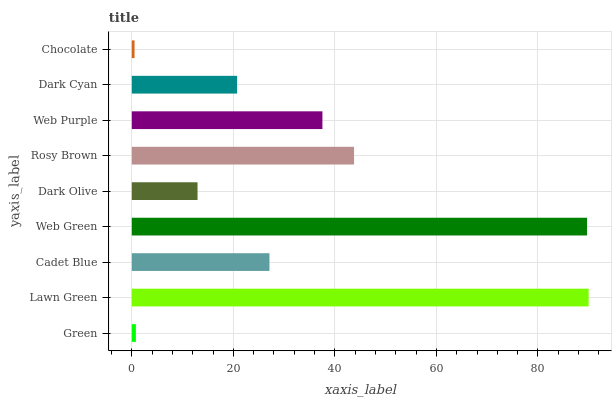Is Chocolate the minimum?
Answer yes or no. Yes. Is Lawn Green the maximum?
Answer yes or no. Yes. Is Cadet Blue the minimum?
Answer yes or no. No. Is Cadet Blue the maximum?
Answer yes or no. No. Is Lawn Green greater than Cadet Blue?
Answer yes or no. Yes. Is Cadet Blue less than Lawn Green?
Answer yes or no. Yes. Is Cadet Blue greater than Lawn Green?
Answer yes or no. No. Is Lawn Green less than Cadet Blue?
Answer yes or no. No. Is Cadet Blue the high median?
Answer yes or no. Yes. Is Cadet Blue the low median?
Answer yes or no. Yes. Is Chocolate the high median?
Answer yes or no. No. Is Dark Cyan the low median?
Answer yes or no. No. 